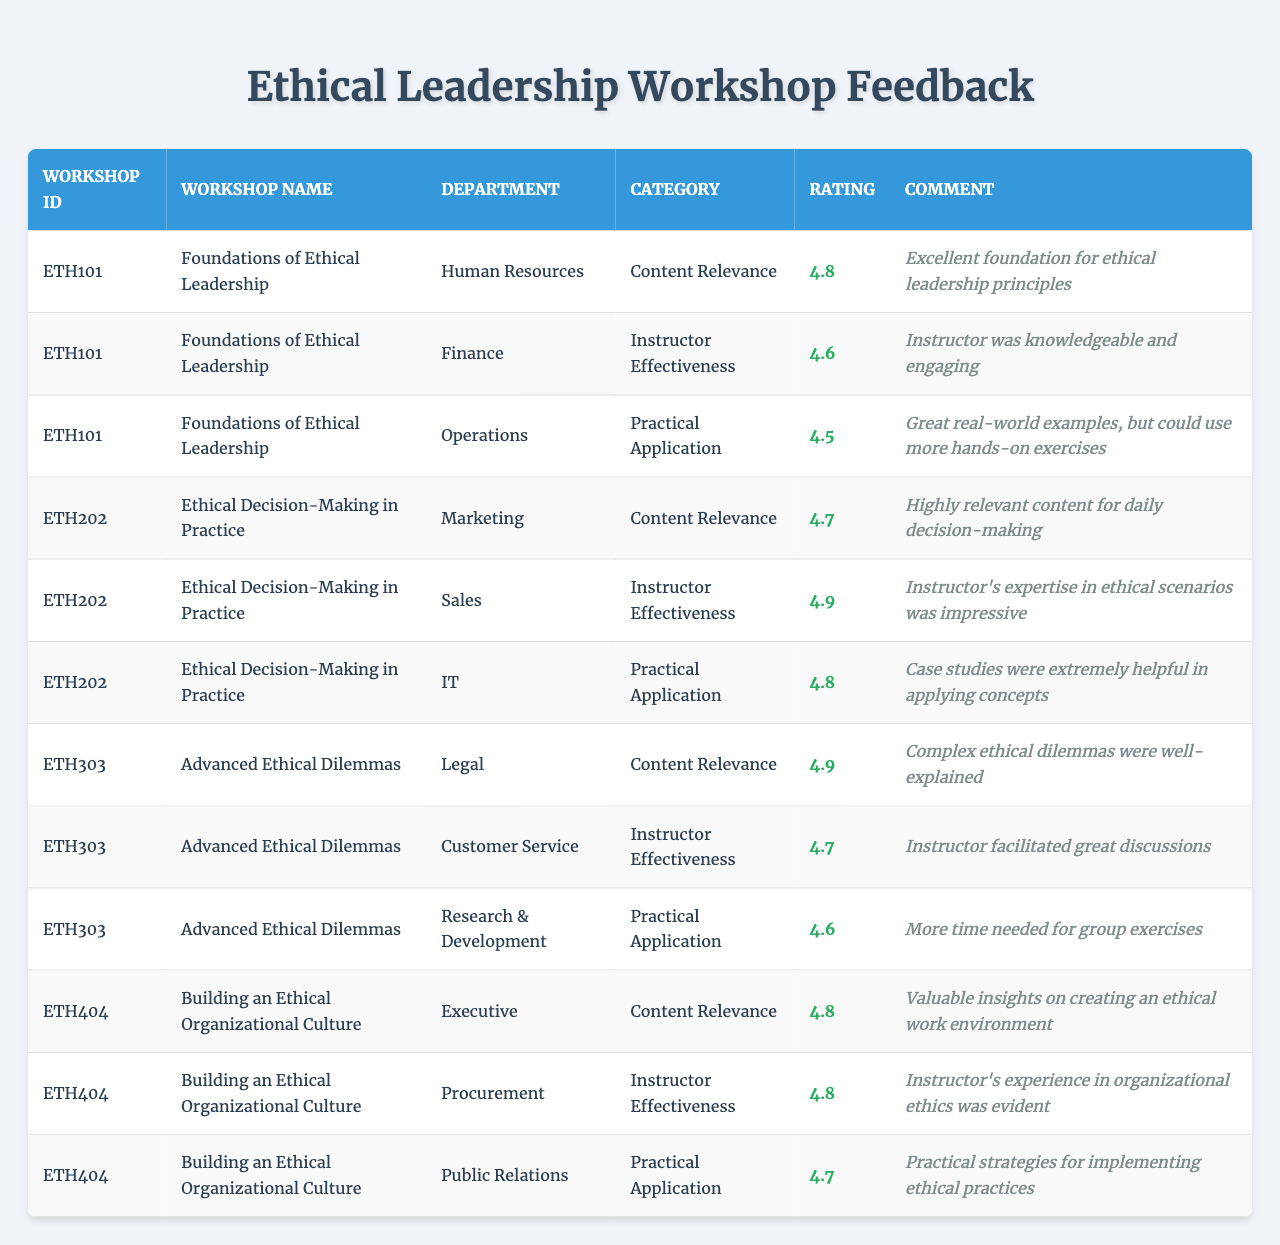What is the highest rating score in the table? The highest rating score can be identified by looking at the "Rating" column. The maximum value from the scores listed is 4.9.
Answer: 4.9 Which workshop received the lowest rating score? To find the lowest rating score, compare all the scores. Upon reviewing them, the lowest score is 4.5, attributed to the workshop "Foundations of Ethical Leadership" under the category "Practical Application."
Answer: Foundations of Ethical Leadership How many workshops have a content relevance rating of 4.8 or higher? Count the number of times the rating for "Content Relevance" is 4.8 or more. In the table, there are three instances for this, each for the workshops ETH101, ETH202, and ETH404.
Answer: 3 What is the average rating score across all workshops? To find the average, add all the rating scores: 4.8 + 4.6 + 4.5 + 4.7 + 4.9 + 4.8 + 4.9 + 4.7 + 4.6 + 4.8 + 4.8 + 4.7 = 57.4, and then divide by the number of ratings (12). Thus, the average is 57.4 / 12 = 4.7833333, which rounds to approximately 4.78.
Answer: 4.78 Do all workshops have at least one category rated above 4.5? Check if each workshop has at least one category rating that exceeds 4.5. By reviewing the scores, it's clear that all workshops listed have ratings above 4.5 in their respective categories.
Answer: Yes Which department rated the workshop "Advanced Ethical Dilemmas" highest, and what was the score? Look at the ratings for "Advanced Ethical Dilemmas" from the respective departments (Legal, Customer Service, and Research & Development) and find the highest score among them, which is 4.9 from the Legal department.
Answer: Legal, 4.9 If we consider only the "Instructor Effectiveness" category, what is the sum of the ratings? Identify ratings under the "Instructor Effectiveness" category from the table. The scores are 4.6, 4.9, 4.7, 4.8, and 4.8, totaling them: 4.6 + 4.9 + 4.7 + 4.8 + 4.8 = 24.8.
Answer: 24.8 Which workshop has the second highest average rating across all categories? Calculate the average rating for each workshop by taking the mean of their respective scores. After evaluating, "Ethical Decision-Making in Practice" has an average rating of 4.8, which is the second highest after "Foundations of Ethical Leadership."
Answer: Ethical Decision-Making in Practice Identify the department with the most participants in the workshops. Count the number of occurrences for each department in the "Department" column. Upon examination, all departments have only one participant, indicating that no department has more participants than the others.
Answer: All are equal 